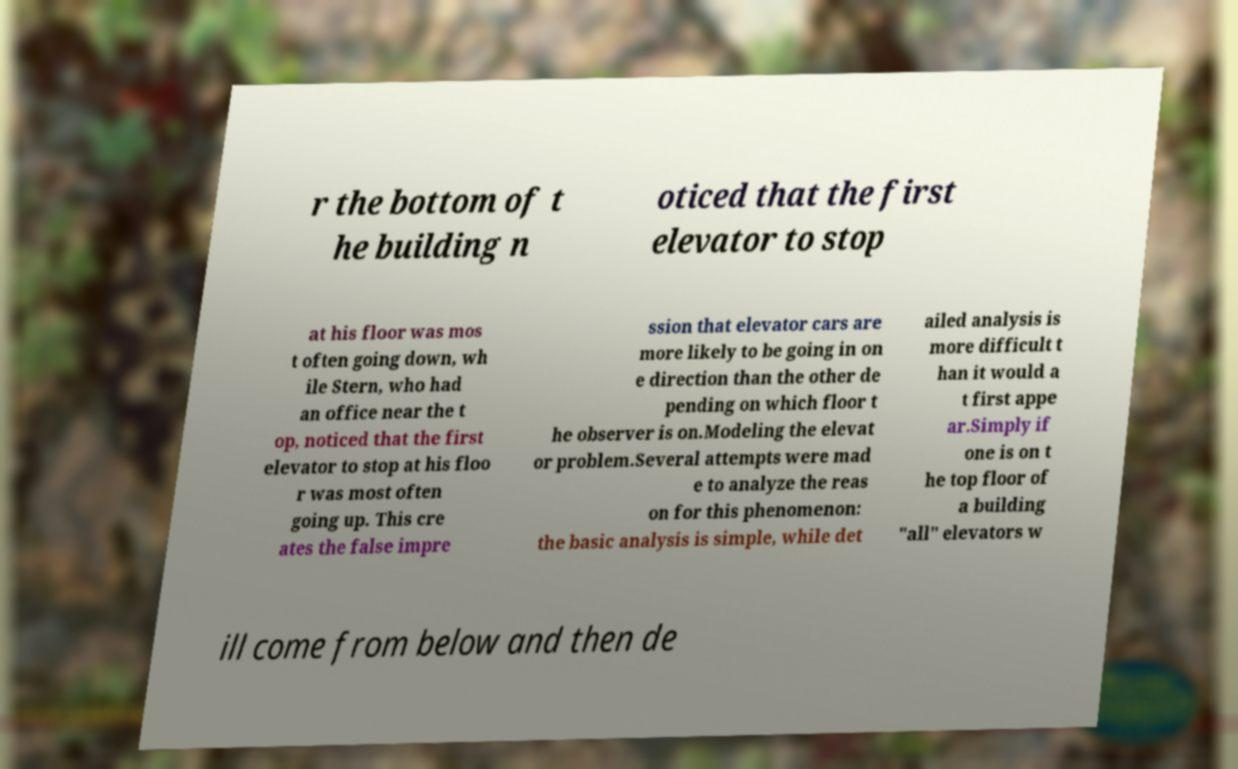What messages or text are displayed in this image? I need them in a readable, typed format. r the bottom of t he building n oticed that the first elevator to stop at his floor was mos t often going down, wh ile Stern, who had an office near the t op, noticed that the first elevator to stop at his floo r was most often going up. This cre ates the false impre ssion that elevator cars are more likely to be going in on e direction than the other de pending on which floor t he observer is on.Modeling the elevat or problem.Several attempts were mad e to analyze the reas on for this phenomenon: the basic analysis is simple, while det ailed analysis is more difficult t han it would a t first appe ar.Simply if one is on t he top floor of a building "all" elevators w ill come from below and then de 